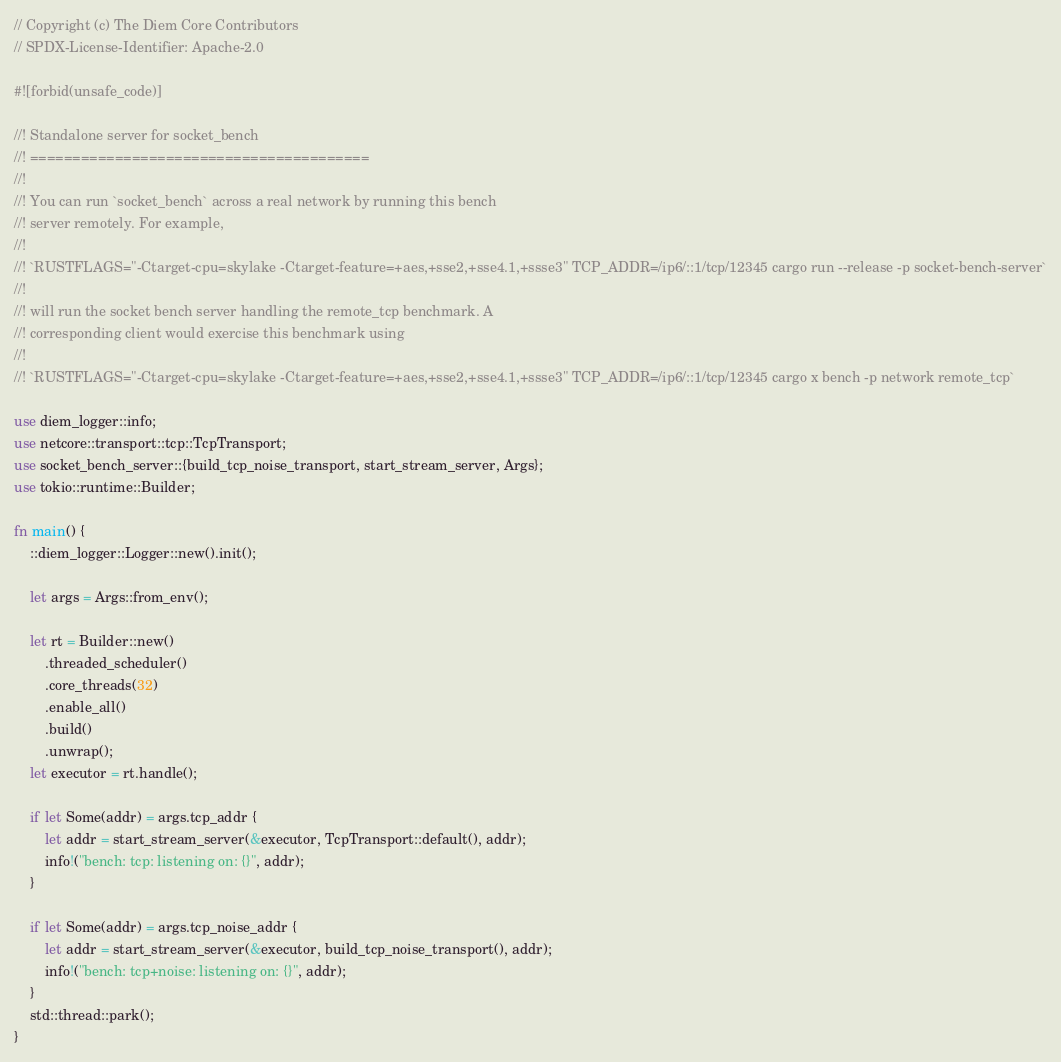<code> <loc_0><loc_0><loc_500><loc_500><_Rust_>// Copyright (c) The Diem Core Contributors
// SPDX-License-Identifier: Apache-2.0

#![forbid(unsafe_code)]

//! Standalone server for socket_bench
//! ========================================
//!
//! You can run `socket_bench` across a real network by running this bench
//! server remotely. For example,
//!
//! `RUSTFLAGS="-Ctarget-cpu=skylake -Ctarget-feature=+aes,+sse2,+sse4.1,+ssse3" TCP_ADDR=/ip6/::1/tcp/12345 cargo run --release -p socket-bench-server`
//!
//! will run the socket bench server handling the remote_tcp benchmark. A
//! corresponding client would exercise this benchmark using
//!
//! `RUSTFLAGS="-Ctarget-cpu=skylake -Ctarget-feature=+aes,+sse2,+sse4.1,+ssse3" TCP_ADDR=/ip6/::1/tcp/12345 cargo x bench -p network remote_tcp`

use diem_logger::info;
use netcore::transport::tcp::TcpTransport;
use socket_bench_server::{build_tcp_noise_transport, start_stream_server, Args};
use tokio::runtime::Builder;

fn main() {
    ::diem_logger::Logger::new().init();

    let args = Args::from_env();

    let rt = Builder::new()
        .threaded_scheduler()
        .core_threads(32)
        .enable_all()
        .build()
        .unwrap();
    let executor = rt.handle();

    if let Some(addr) = args.tcp_addr {
        let addr = start_stream_server(&executor, TcpTransport::default(), addr);
        info!("bench: tcp: listening on: {}", addr);
    }

    if let Some(addr) = args.tcp_noise_addr {
        let addr = start_stream_server(&executor, build_tcp_noise_transport(), addr);
        info!("bench: tcp+noise: listening on: {}", addr);
    }
    std::thread::park();
}
</code> 